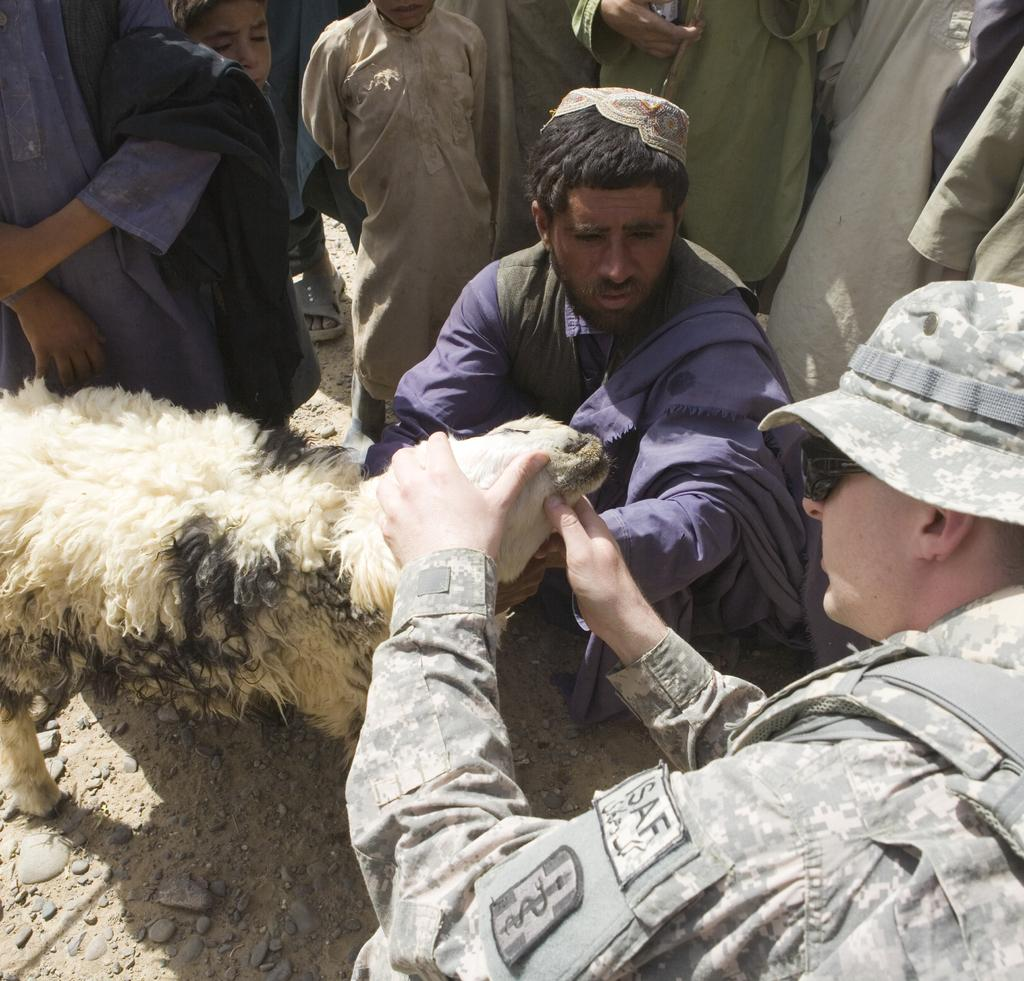What type of animal is in the image? There is a sheep in the image. Are there any people present in the image? Yes, there are people around the sheep. Can you describe the man holding the sheep's head? The man is wearing a cap and uniform. What position is the man in the blue dress in? The man in the blue dress is in a crouch position. What type of night feast is being prepared in the image? There is no mention of a night feast or any food preparation in the image. The image features a sheep and people around it. 